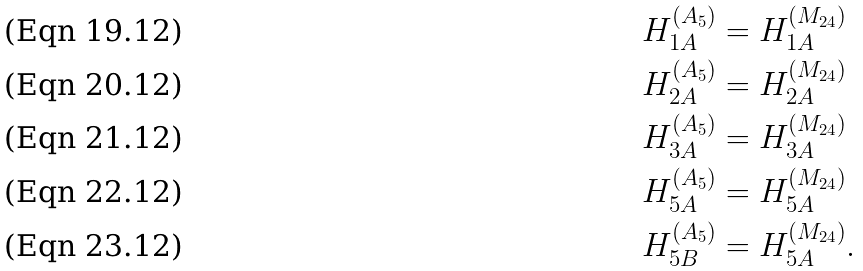Convert formula to latex. <formula><loc_0><loc_0><loc_500><loc_500>H _ { 1 A } ^ { ( A _ { 5 } ) } & = H _ { 1 A } ^ { ( M _ { 2 4 } ) } \\ H _ { 2 A } ^ { ( A _ { 5 } ) } & = H _ { 2 A } ^ { ( M _ { 2 4 } ) } \\ H _ { 3 A } ^ { ( A _ { 5 } ) } & = H _ { 3 A } ^ { ( M _ { 2 4 } ) } \\ H _ { 5 A } ^ { ( A _ { 5 } ) } & = H _ { 5 A } ^ { ( M _ { 2 4 } ) } \\ H _ { 5 B } ^ { ( A _ { 5 } ) } & = H _ { 5 A } ^ { ( M _ { 2 4 } ) } .</formula> 